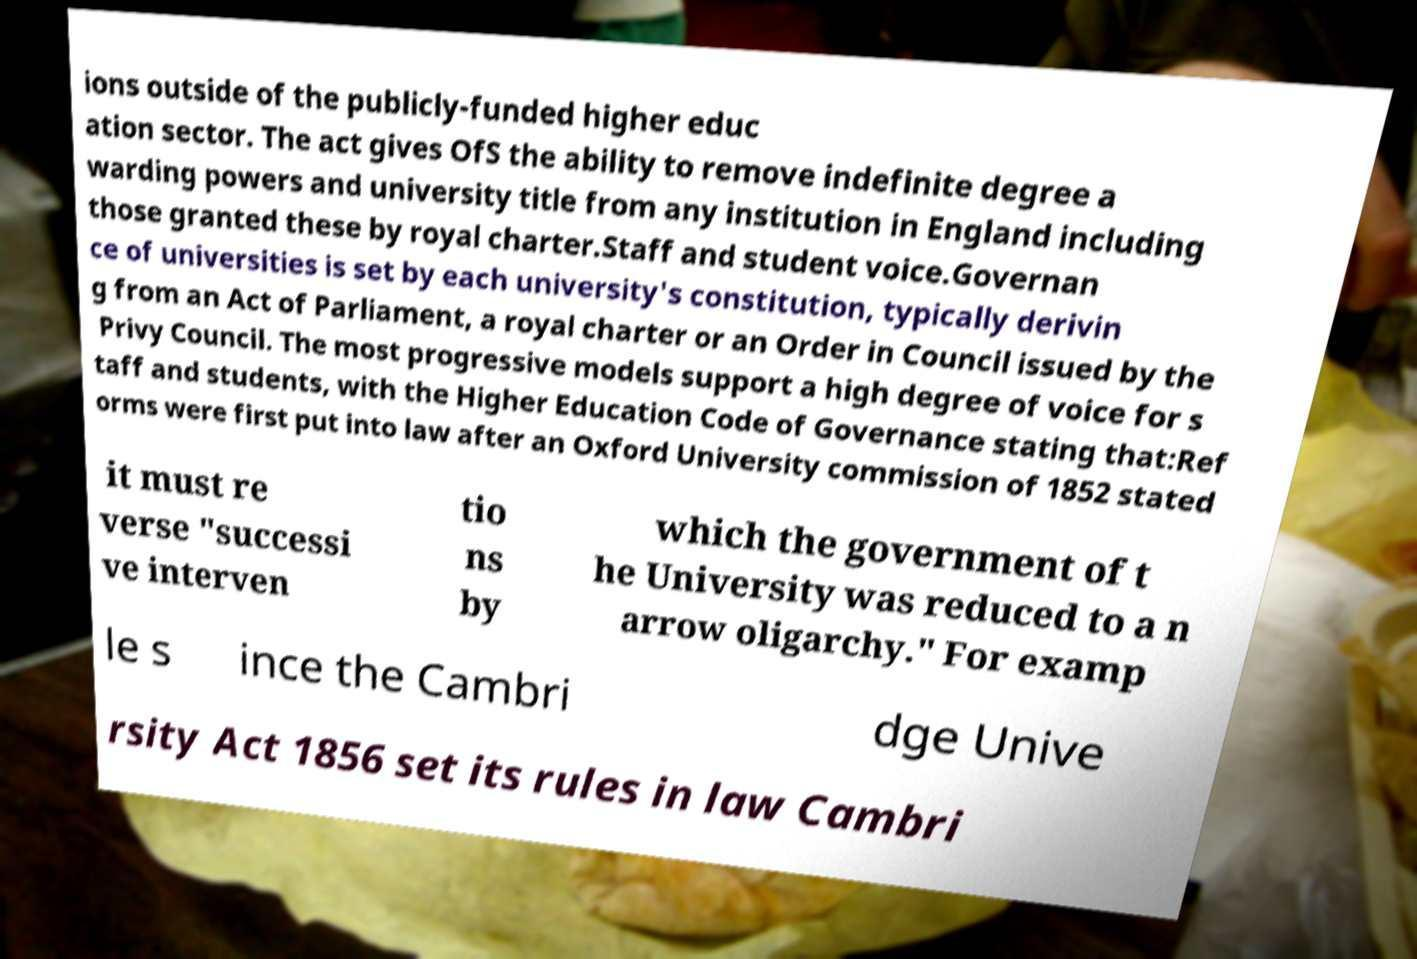There's text embedded in this image that I need extracted. Can you transcribe it verbatim? ions outside of the publicly-funded higher educ ation sector. The act gives OfS the ability to remove indefinite degree a warding powers and university title from any institution in England including those granted these by royal charter.Staff and student voice.Governan ce of universities is set by each university's constitution, typically derivin g from an Act of Parliament, a royal charter or an Order in Council issued by the Privy Council. The most progressive models support a high degree of voice for s taff and students, with the Higher Education Code of Governance stating that:Ref orms were first put into law after an Oxford University commission of 1852 stated it must re verse "successi ve interven tio ns by which the government of t he University was reduced to a n arrow oligarchy." For examp le s ince the Cambri dge Unive rsity Act 1856 set its rules in law Cambri 